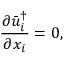<formula> <loc_0><loc_0><loc_500><loc_500>{ \frac { { \partial \bar { u } _ { i } ^ { \dag } } } { { \partial { x _ { i } } } } } = 0 ,</formula> 